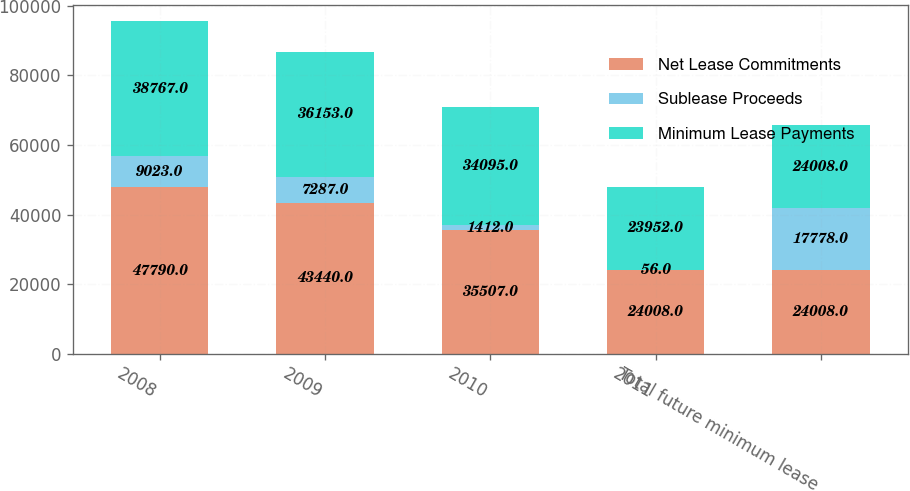Convert chart. <chart><loc_0><loc_0><loc_500><loc_500><stacked_bar_chart><ecel><fcel>2008<fcel>2009<fcel>2010<fcel>2011<fcel>Total future minimum lease<nl><fcel>Net Lease Commitments<fcel>47790<fcel>43440<fcel>35507<fcel>24008<fcel>24008<nl><fcel>Sublease Proceeds<fcel>9023<fcel>7287<fcel>1412<fcel>56<fcel>17778<nl><fcel>Minimum Lease Payments<fcel>38767<fcel>36153<fcel>34095<fcel>23952<fcel>24008<nl></chart> 